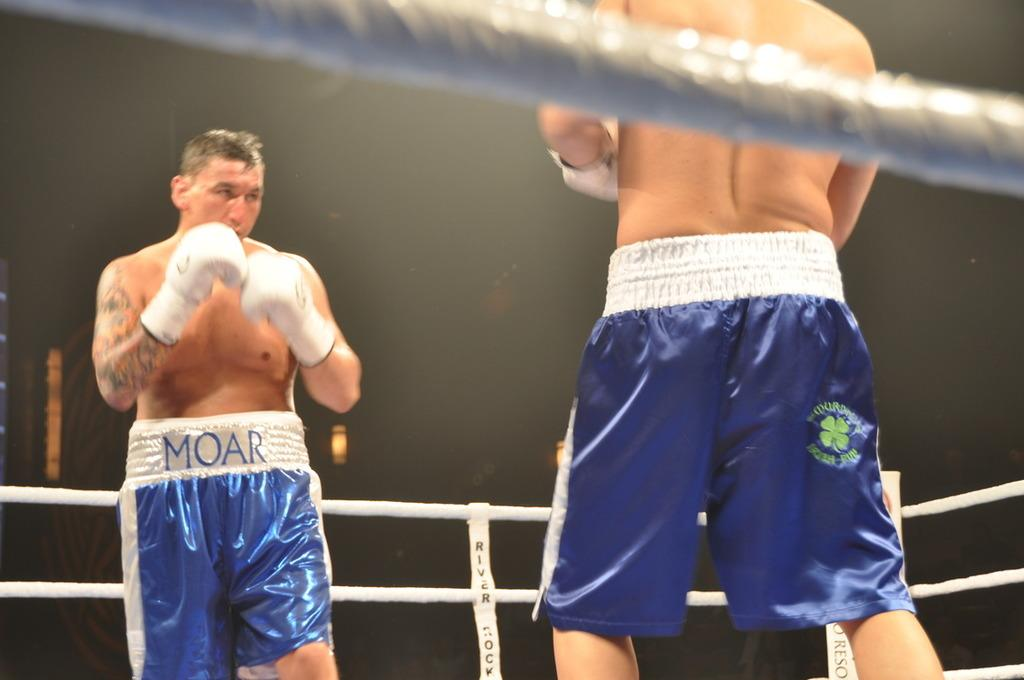<image>
Create a compact narrative representing the image presented. A man in shorts that say MOAR is boxing another man in shorts with a clover on them. 